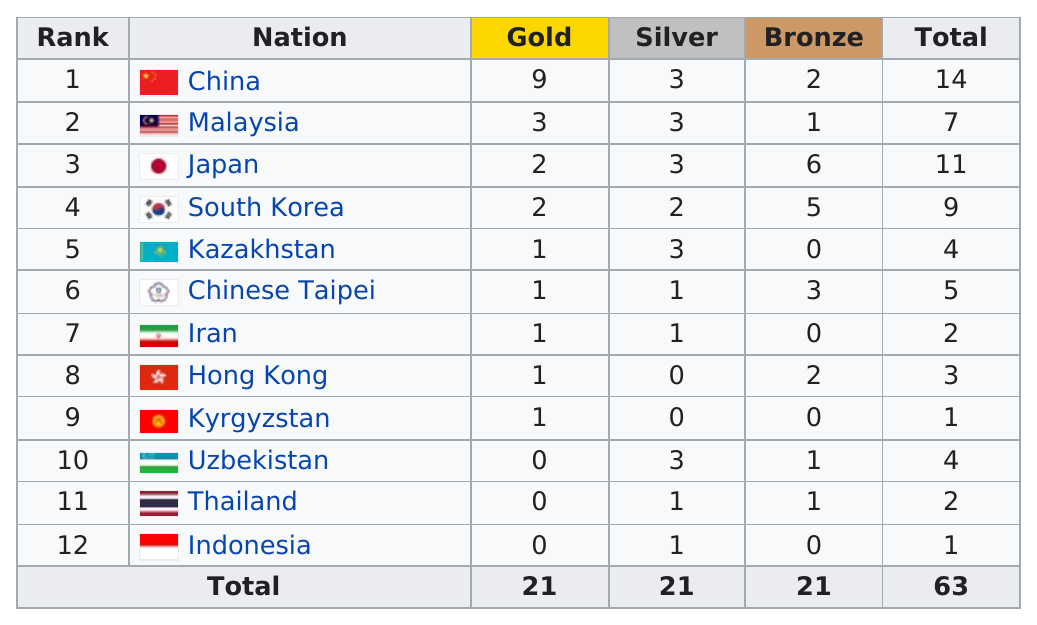Indicate a few pertinent items in this graphic. The nation of China holds the first rank. Of the nations that won only one medal, two of them are: The countries of China, Malaysia, Japan, and South Korea had more gold medals than Kazakhstan. There are four nations that did not earn any bronze medals. China had the highest total of all countries. 